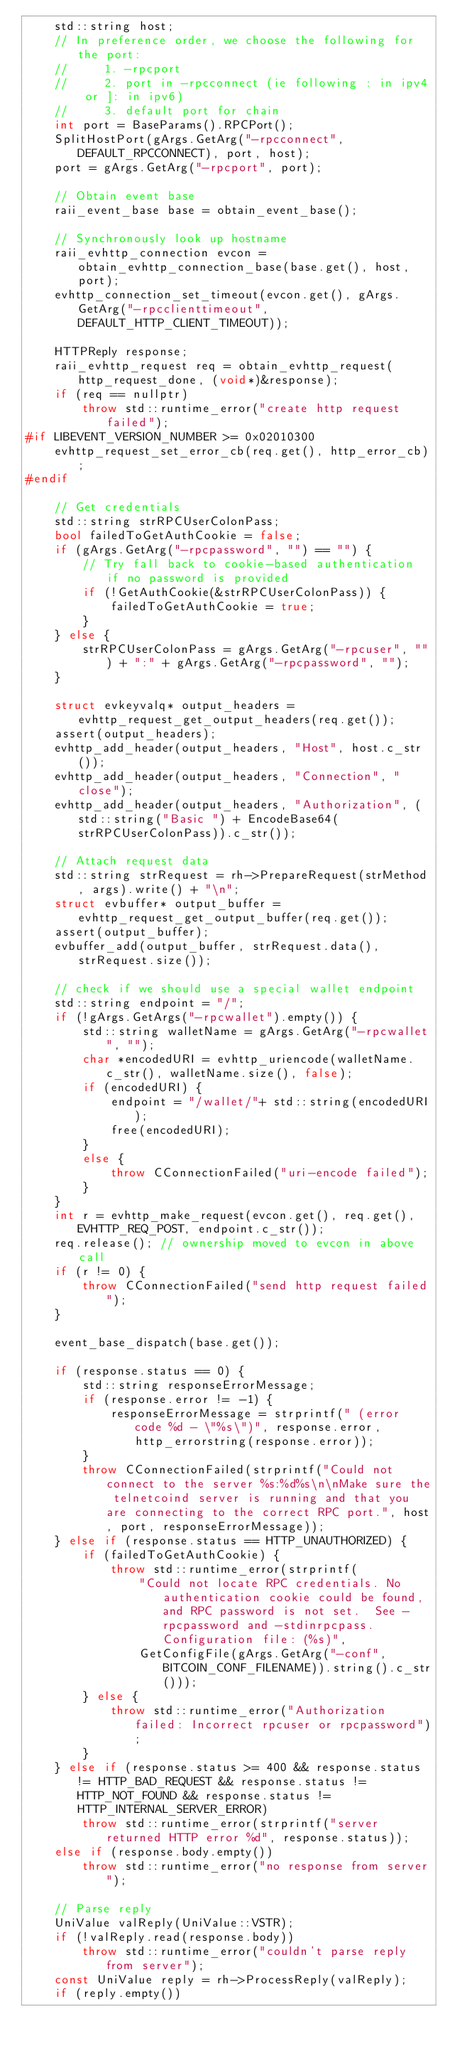<code> <loc_0><loc_0><loc_500><loc_500><_C++_>    std::string host;
    // In preference order, we choose the following for the port:
    //     1. -rpcport
    //     2. port in -rpcconnect (ie following : in ipv4 or ]: in ipv6)
    //     3. default port for chain
    int port = BaseParams().RPCPort();
    SplitHostPort(gArgs.GetArg("-rpcconnect", DEFAULT_RPCCONNECT), port, host);
    port = gArgs.GetArg("-rpcport", port);

    // Obtain event base
    raii_event_base base = obtain_event_base();

    // Synchronously look up hostname
    raii_evhttp_connection evcon = obtain_evhttp_connection_base(base.get(), host, port);
    evhttp_connection_set_timeout(evcon.get(), gArgs.GetArg("-rpcclienttimeout", DEFAULT_HTTP_CLIENT_TIMEOUT));

    HTTPReply response;
    raii_evhttp_request req = obtain_evhttp_request(http_request_done, (void*)&response);
    if (req == nullptr)
        throw std::runtime_error("create http request failed");
#if LIBEVENT_VERSION_NUMBER >= 0x02010300
    evhttp_request_set_error_cb(req.get(), http_error_cb);
#endif

    // Get credentials
    std::string strRPCUserColonPass;
    bool failedToGetAuthCookie = false;
    if (gArgs.GetArg("-rpcpassword", "") == "") {
        // Try fall back to cookie-based authentication if no password is provided
        if (!GetAuthCookie(&strRPCUserColonPass)) {
            failedToGetAuthCookie = true;
        }
    } else {
        strRPCUserColonPass = gArgs.GetArg("-rpcuser", "") + ":" + gArgs.GetArg("-rpcpassword", "");
    }

    struct evkeyvalq* output_headers = evhttp_request_get_output_headers(req.get());
    assert(output_headers);
    evhttp_add_header(output_headers, "Host", host.c_str());
    evhttp_add_header(output_headers, "Connection", "close");
    evhttp_add_header(output_headers, "Authorization", (std::string("Basic ") + EncodeBase64(strRPCUserColonPass)).c_str());

    // Attach request data
    std::string strRequest = rh->PrepareRequest(strMethod, args).write() + "\n";
    struct evbuffer* output_buffer = evhttp_request_get_output_buffer(req.get());
    assert(output_buffer);
    evbuffer_add(output_buffer, strRequest.data(), strRequest.size());

    // check if we should use a special wallet endpoint
    std::string endpoint = "/";
    if (!gArgs.GetArgs("-rpcwallet").empty()) {
        std::string walletName = gArgs.GetArg("-rpcwallet", "");
        char *encodedURI = evhttp_uriencode(walletName.c_str(), walletName.size(), false);
        if (encodedURI) {
            endpoint = "/wallet/"+ std::string(encodedURI);
            free(encodedURI);
        }
        else {
            throw CConnectionFailed("uri-encode failed");
        }
    }
    int r = evhttp_make_request(evcon.get(), req.get(), EVHTTP_REQ_POST, endpoint.c_str());
    req.release(); // ownership moved to evcon in above call
    if (r != 0) {
        throw CConnectionFailed("send http request failed");
    }

    event_base_dispatch(base.get());

    if (response.status == 0) {
        std::string responseErrorMessage;
        if (response.error != -1) {
            responseErrorMessage = strprintf(" (error code %d - \"%s\")", response.error, http_errorstring(response.error));
        }
        throw CConnectionFailed(strprintf("Could not connect to the server %s:%d%s\n\nMake sure the telnetcoind server is running and that you are connecting to the correct RPC port.", host, port, responseErrorMessage));
    } else if (response.status == HTTP_UNAUTHORIZED) {
        if (failedToGetAuthCookie) {
            throw std::runtime_error(strprintf(
                "Could not locate RPC credentials. No authentication cookie could be found, and RPC password is not set.  See -rpcpassword and -stdinrpcpass.  Configuration file: (%s)",
                GetConfigFile(gArgs.GetArg("-conf", BITCOIN_CONF_FILENAME)).string().c_str()));
        } else {
            throw std::runtime_error("Authorization failed: Incorrect rpcuser or rpcpassword");
        }
    } else if (response.status >= 400 && response.status != HTTP_BAD_REQUEST && response.status != HTTP_NOT_FOUND && response.status != HTTP_INTERNAL_SERVER_ERROR)
        throw std::runtime_error(strprintf("server returned HTTP error %d", response.status));
    else if (response.body.empty())
        throw std::runtime_error("no response from server");

    // Parse reply
    UniValue valReply(UniValue::VSTR);
    if (!valReply.read(response.body))
        throw std::runtime_error("couldn't parse reply from server");
    const UniValue reply = rh->ProcessReply(valReply);
    if (reply.empty())</code> 